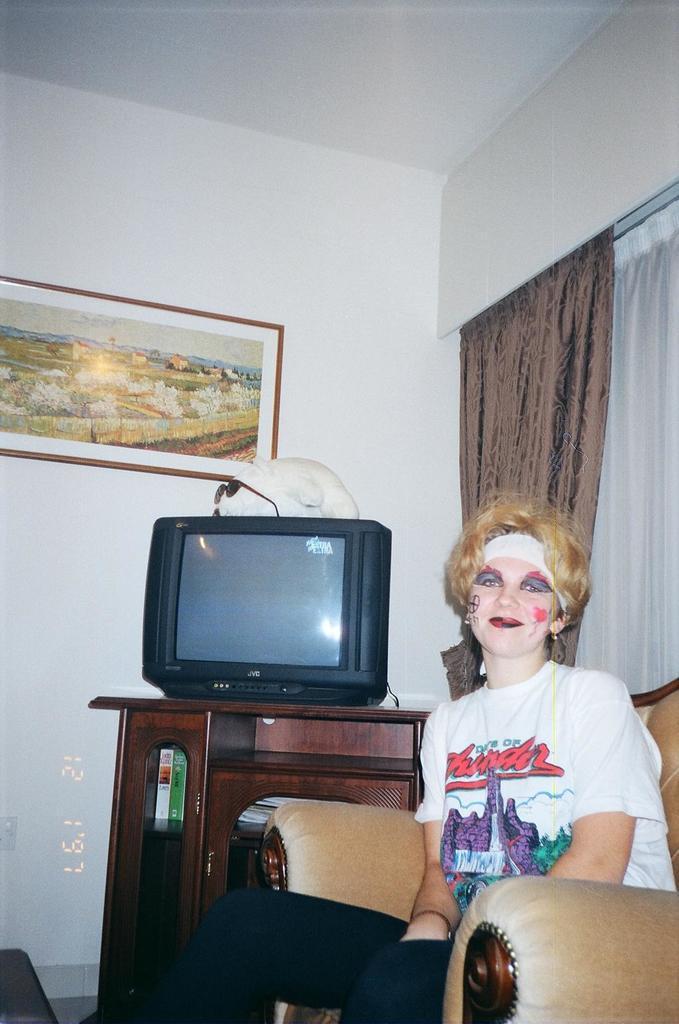In one or two sentences, can you explain what this image depicts? It is a living room , a woman is sitting in the sofa behind her there is a cupboard and a tv over it and also a doll upon the television behind it there is a white color wall in the background there is a curtain. 